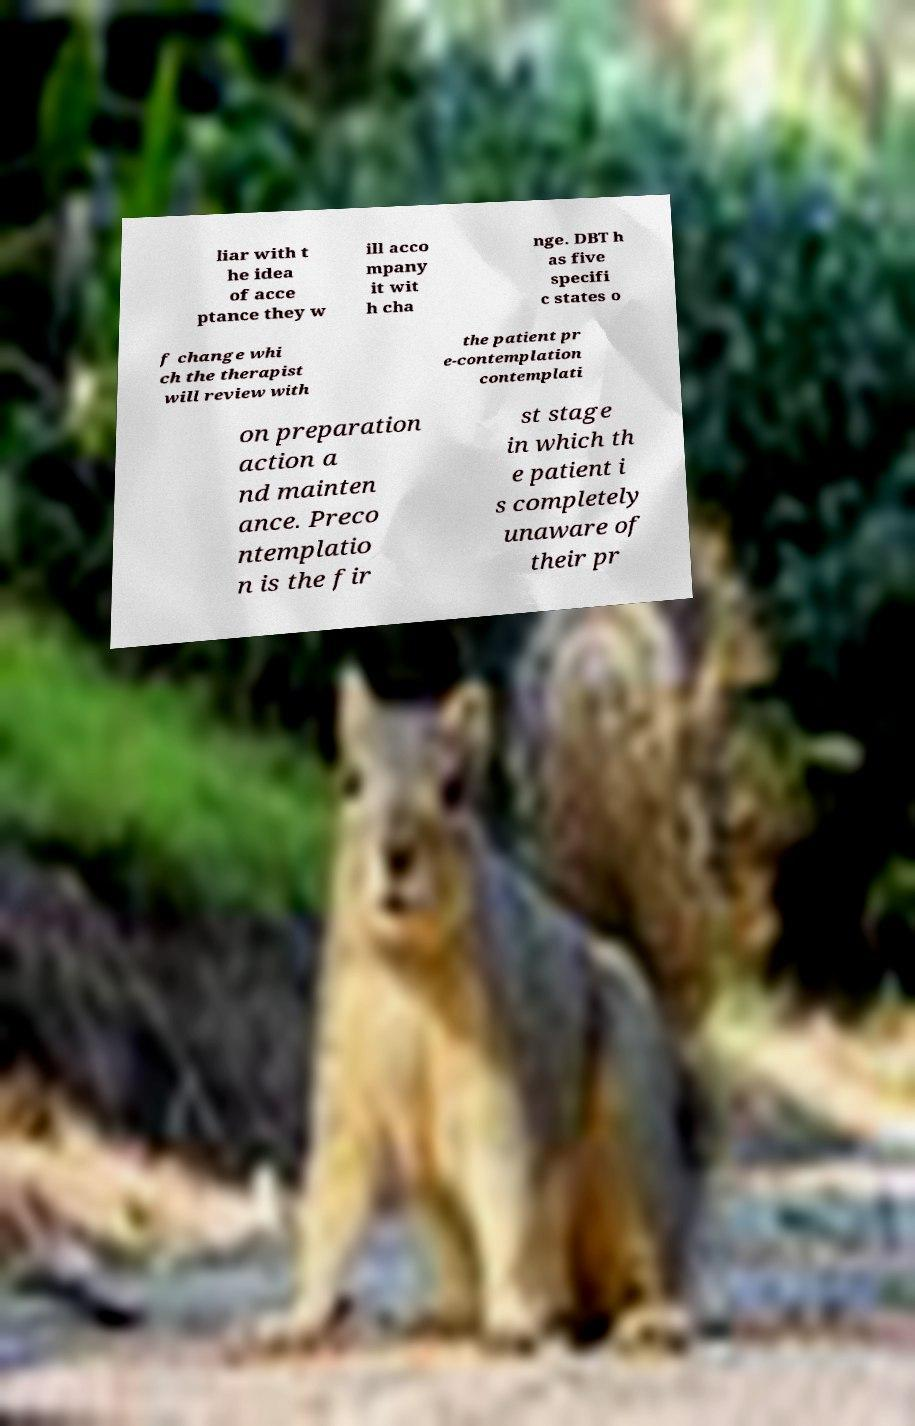What messages or text are displayed in this image? I need them in a readable, typed format. liar with t he idea of acce ptance they w ill acco mpany it wit h cha nge. DBT h as five specifi c states o f change whi ch the therapist will review with the patient pr e-contemplation contemplati on preparation action a nd mainten ance. Preco ntemplatio n is the fir st stage in which th e patient i s completely unaware of their pr 